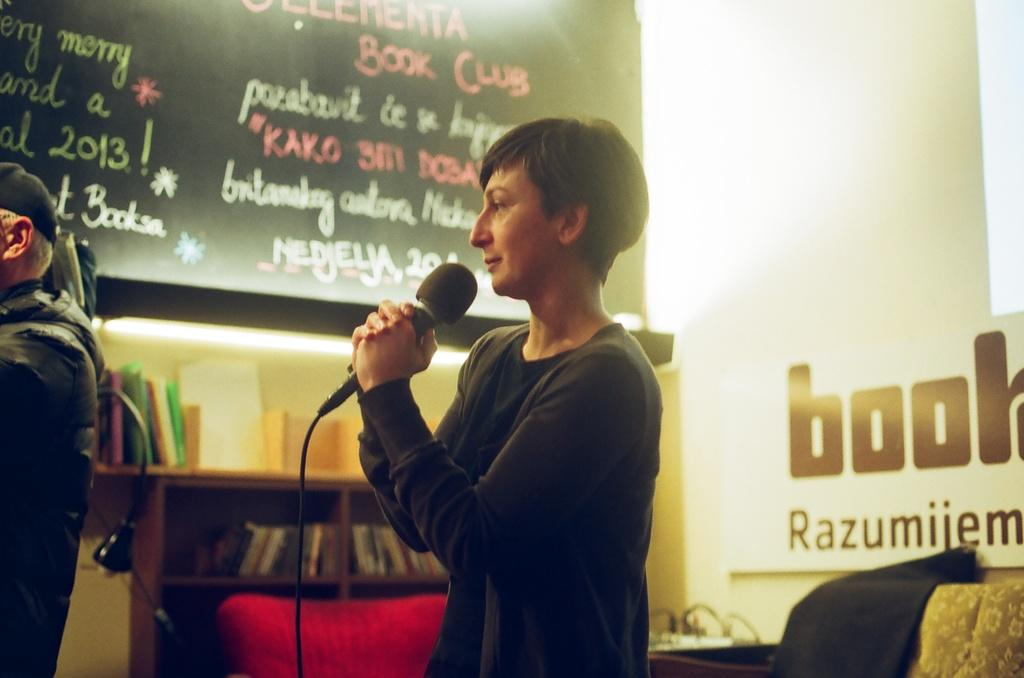What is the person holding in the image? The person is holding a mic in the image. Who is standing in front of the person holding the mic? There is another person standing in front of the person holding the mic. What can be seen to the right of the person holding the mic? There is a board to the right of the person holding the mic. What is located to the right of the board? There is a cupboard with books inside it to the right of the board. Is the person holding the mic fighting with their brother in the image? There is no mention of a brother or any fighting in the image. The image only shows a person holding a mic and another person standing in front of them, along with a board and a cupboard with books. 